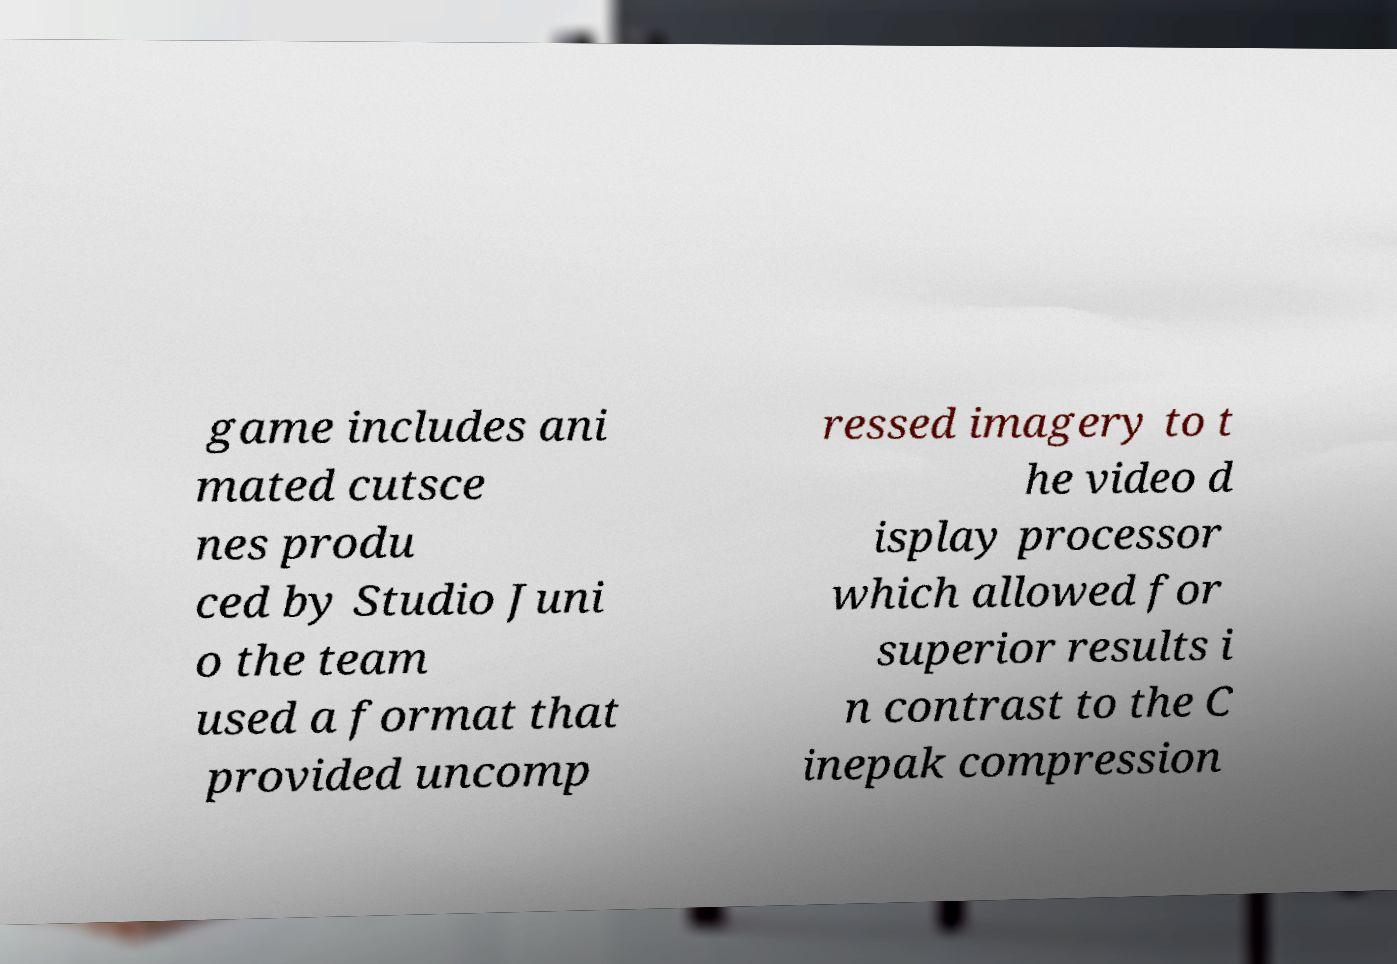Could you extract and type out the text from this image? game includes ani mated cutsce nes produ ced by Studio Juni o the team used a format that provided uncomp ressed imagery to t he video d isplay processor which allowed for superior results i n contrast to the C inepak compression 